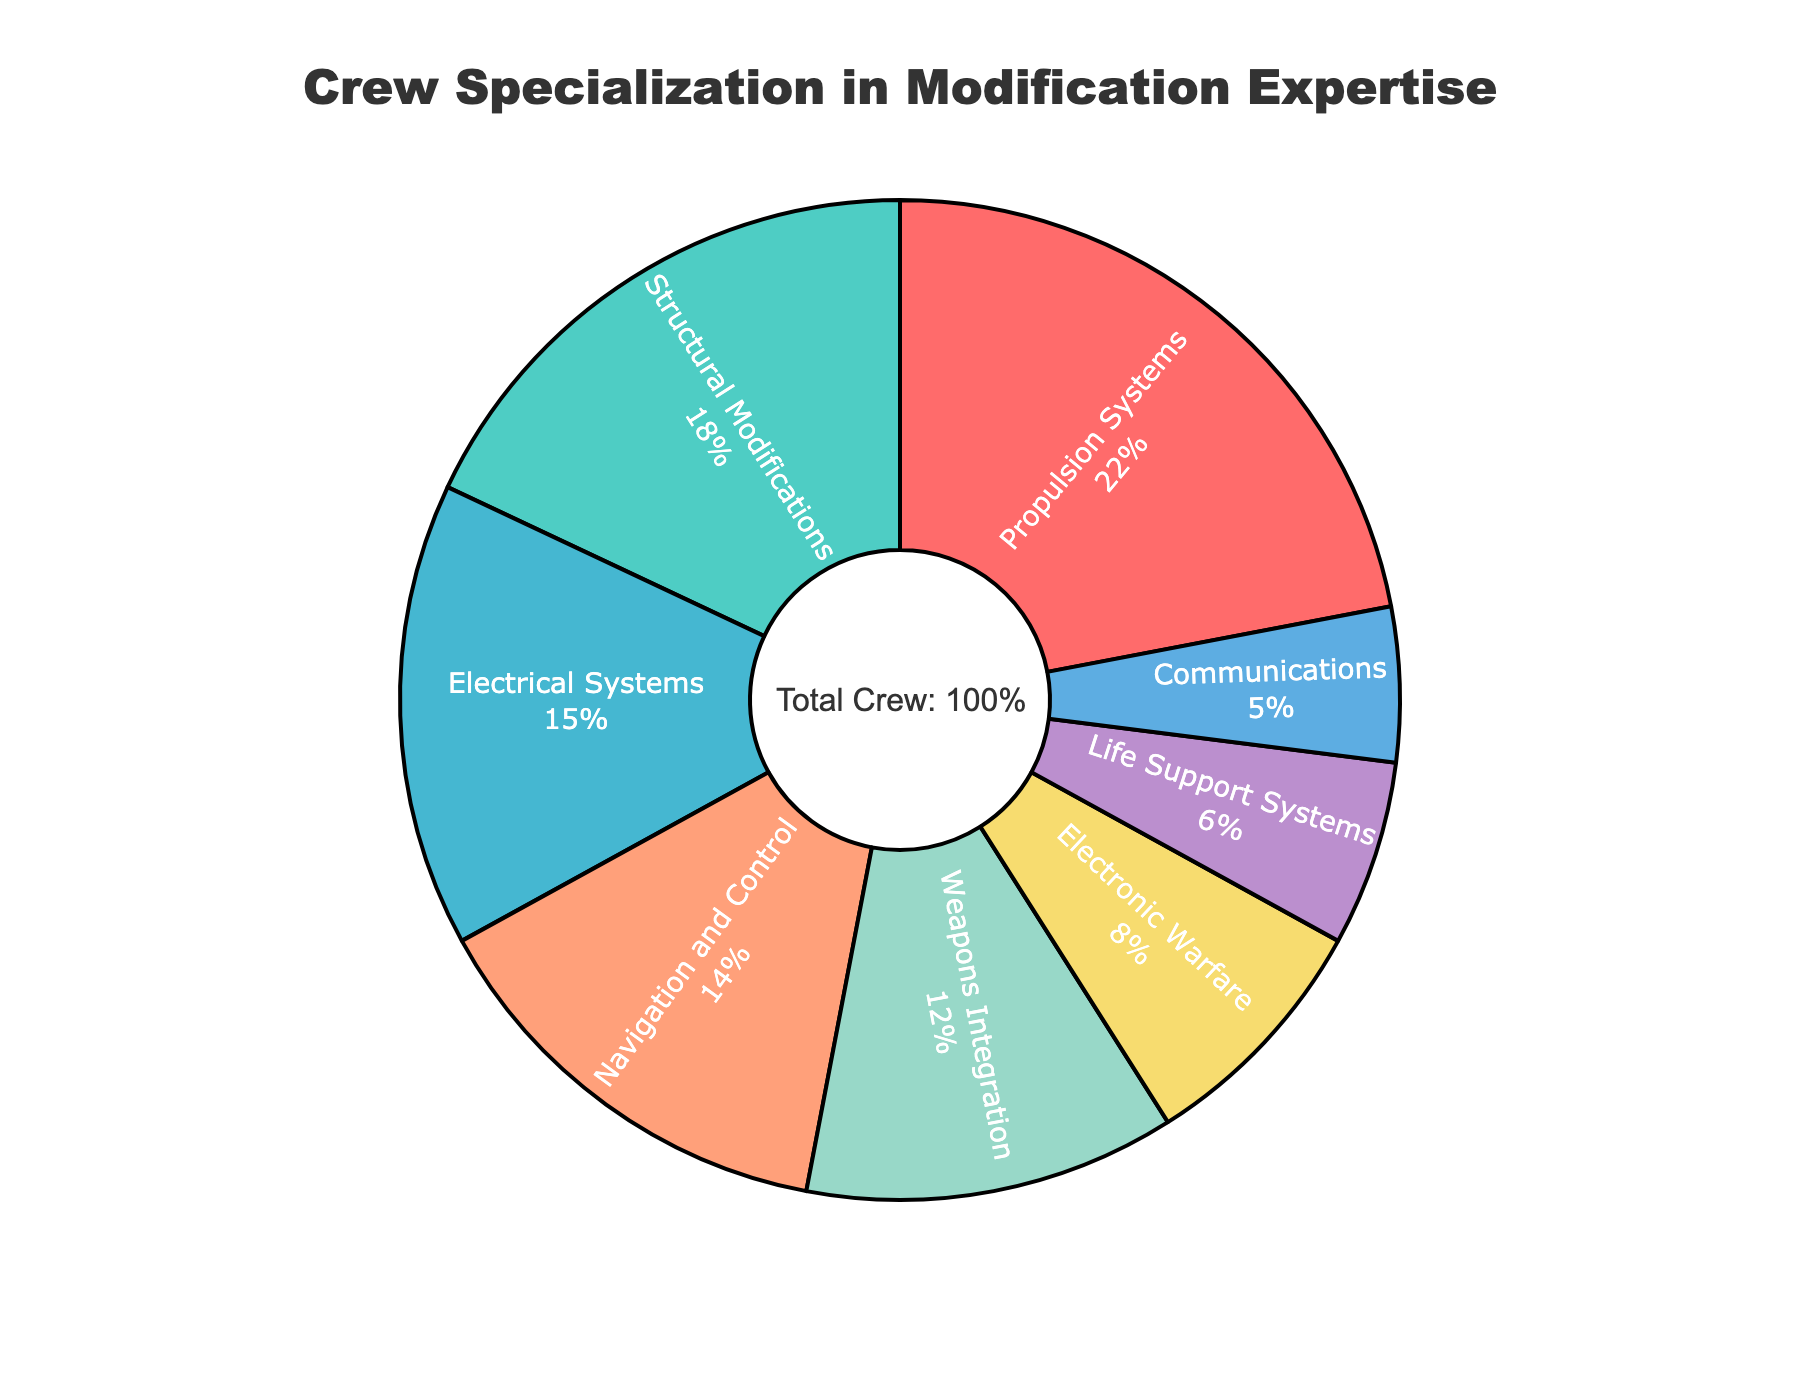What's the combined percentage of crew members specializing in Propulsion Systems and Structural Modifications? Add the percentages for Propulsion Systems (22%) and Structural Modifications (18%). 22 + 18 = 40.
Answer: 40% Which area of expertise has the smallest proportion of crew members? Look for the smallest percentage in the pie chart. Communications has the smallest percentage at 5%.
Answer: Communications How many areas of expertise have a percentage greater than or equal to 14%? Identify the areas with percentages 14% or higher: Propulsion Systems (22%), Structural Modifications (18%), Electrical Systems (15%), and Navigation and Control (14%). There are 4 areas.
Answer: 4 Is the proportion of crew members specializing in Weapons Integration greater than those in Life Support Systems? Compare the percentages of Weapons Integration (12%) and Life Support Systems (6%). 12% is greater than 6%.
Answer: Yes What's the difference in the proportion of crew members between Electronic Warfare and Communications? Subtract the percentage of Communications (5%) from Electronic Warfare (8%). 8 - 5 = 3.
Answer: 3% Which specialization has a higher percentage: Electrical Systems or Navigation and Control? Compare Electrical Systems (15%) with Navigation and Control (14%). 15% is greater than 14%.
Answer: Electrical Systems What's the total percentage of crew members specializing in systems-related areas (Propulsion Systems, Electrical Systems, and Life Support Systems)? Add the percentages for Propulsion Systems (22%), Electrical Systems (15%), and Life Support Systems (6%). 22 + 15 + 6 = 43.
Answer: 43% Order the areas of expertise from the largest to smallest proportion of crew members. List the areas by decreasing percentage: Propulsion Systems (22%), Structural Modifications (18%), Electrical Systems (15%), Navigation and Control (14%), Weapons Integration (12%), Electronic Warfare (8%), Life Support Systems (6%), Communications (5%).
Answer: Propulsion Systems, Structural Modifications, Electrical Systems, Navigation and Control, Weapons Integration, Electronic Warfare, Life Support Systems, Communications What percentage of the crew specializes in Electronic Warfare and Communications together? Add the percentages for Electronic Warfare (8%) and Communications (5%). 8 + 5 = 13.
Answer: 13% If another area was added representing 10% of the crew, would Propulsion Systems still be the largest area of expertise? Compare the new percentage of Propulsion Systems (22%) with the new highest possible percentage (10%). 22% is greater than 10%, so Propulsion Systems remains the largest.
Answer: Yes 